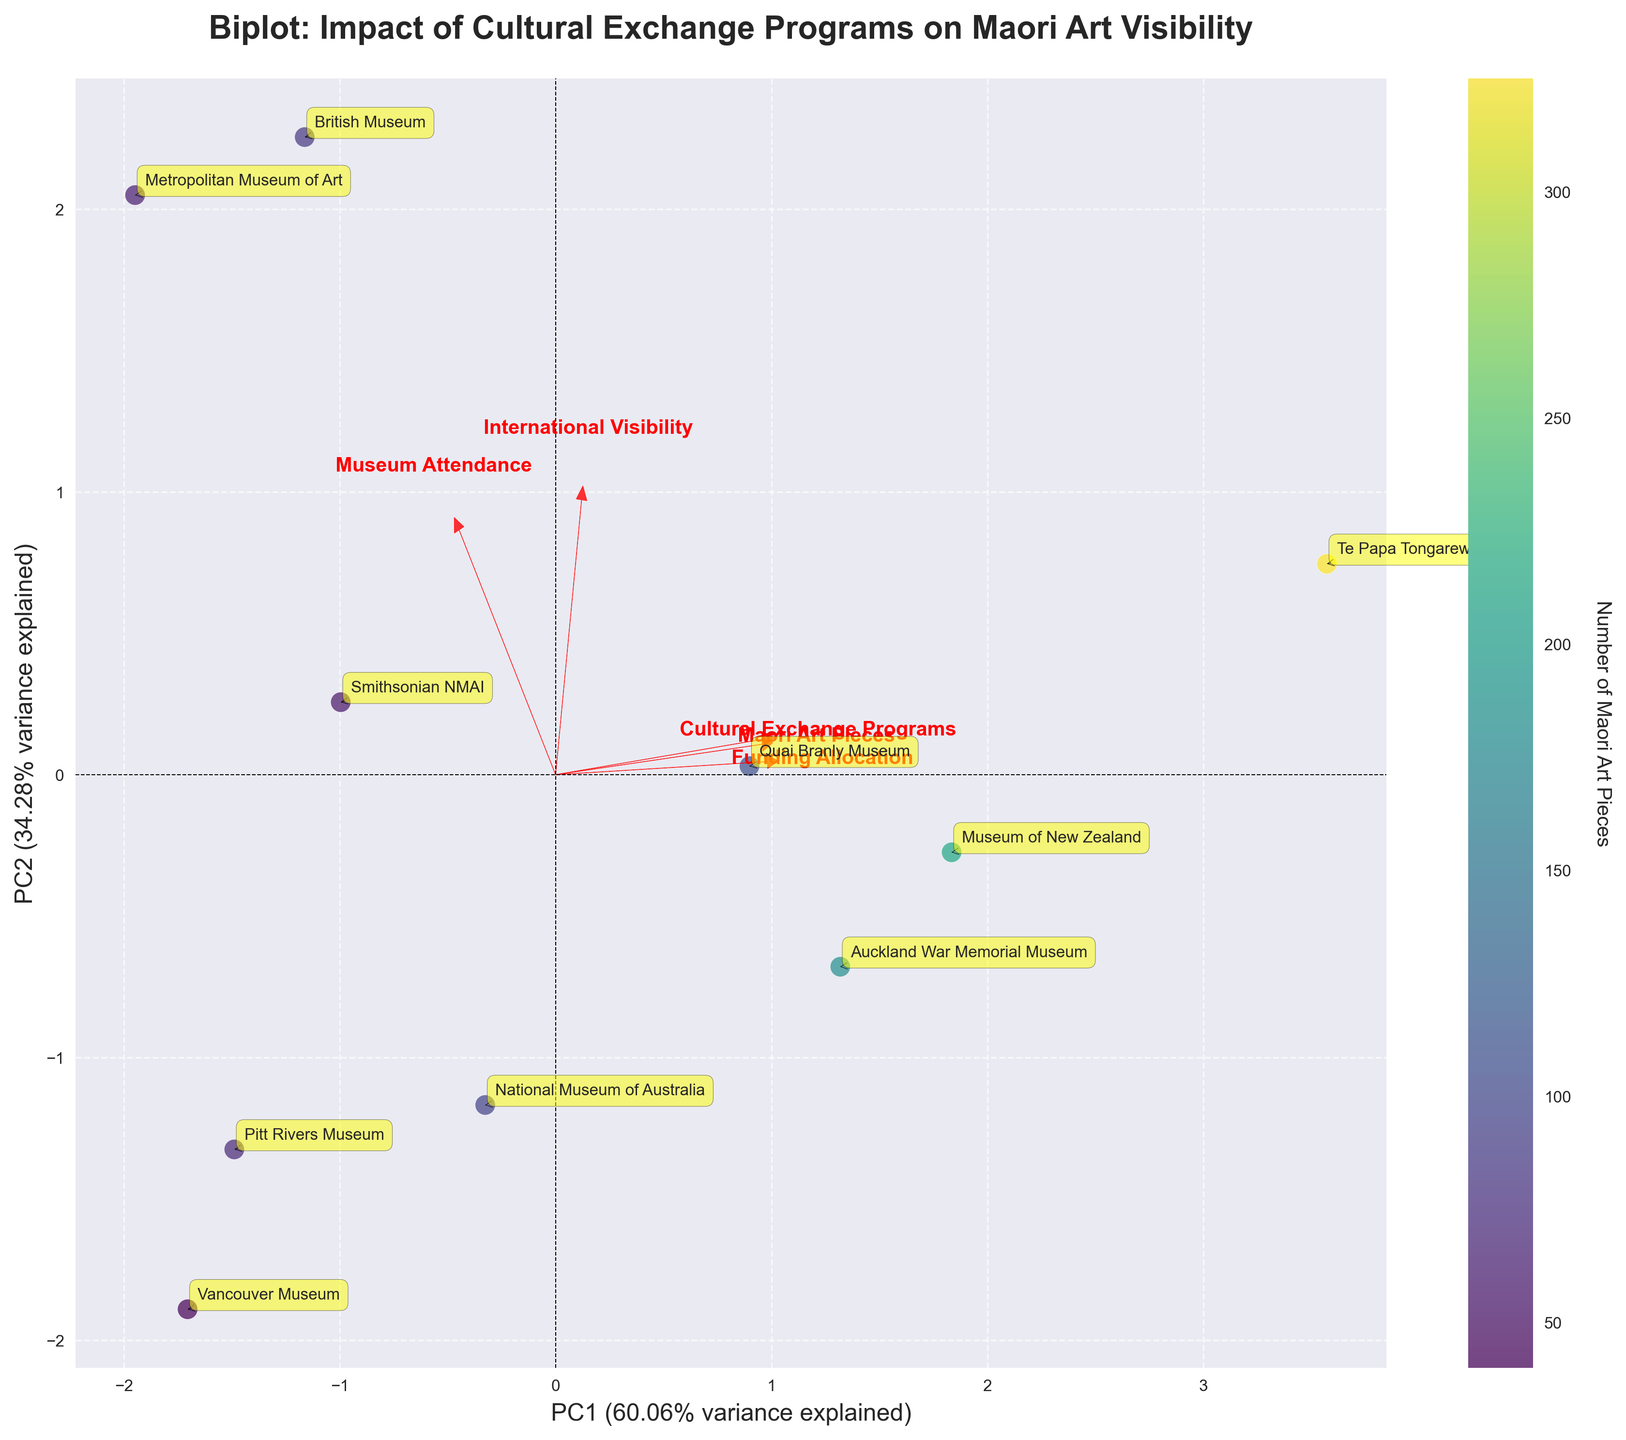What's the title of the figure? The title is usually positioned at the top of the figure. By looking at the top section of the plot, we can see that the title is "Biplot: Impact of Cultural Exchange Programs on Maori Art Visibility"
Answer: Biplot: Impact of Cultural Exchange Programs on Maori Art Visibility Which museum has the highest international visibility score? The international visibility score is marked on the PC1 (x-axis) component. By locating the data points labeled with museum names, we identify the placement along the axis. The British Museum is the furthest to the right, indicating the highest score.
Answer: British Museum Which feature has the most influence on PC1? Features' influence on the principal component directions is represented by the length of the red arrows. The longest arrow in the direction of PC1 represents the highest influence. "International Visibility" has the longest arrow pointing towards PC1.
Answer: International Visibility How many museums have more than 200 Maori Art Pieces? By referring to the color gradient of the scatter points (indicated by the color bar), we need to identify the museums with a dark color which corresponds to more than 200 art pieces. Te Papa Tongarewa and Museum of New Zealand match these criteria.
Answer: 2 Which museum has the lowest number of Maori Art Pieces? The number of Maori Art Pieces is indicated by the color of the scatter points. The color bar shows that the lightest color corresponds to the lowest number of art pieces. Vancouver Museum is the lightest, indicating the lowest number.
Answer: Vancouver Museum Which two features appear to be most correlated based on the loading vectors? Features with loading vectors pointing in the same or directly opposite directions are highly correlated. Observing the directions of the vectors, "International Visibility" and "Museum Attendance" are almost parallel, implying strong correlation.
Answer: International Visibility and Museum Attendance What is the approximate variance explained by PC1 and PC2 combined? The variance explained by each principal component is labeled on the axes. By summing up the percentages from PC1 and PC2, we get around (variance explained by X-axis + Y-axis = 50% + 25%) 75% in total.
Answer: 75% Which museum's attendance is closest to the average attendance across all museums? Visually average the distribution of scatter points along the PC2 (attendance) axis, and identify the midpoint. After comparing the exact placement of the noted museums, National Museum of Australia appears closest to this average point.
Answer: National Museum of Australia Which feature has the smallest influence on PC2? The influence is represented by the shortest red arrow along the PC2 (y-axis) component. Observing the vectors, "Cultural Exchange Programs" has the least influence.
Answer: Cultural Exchange Programs 